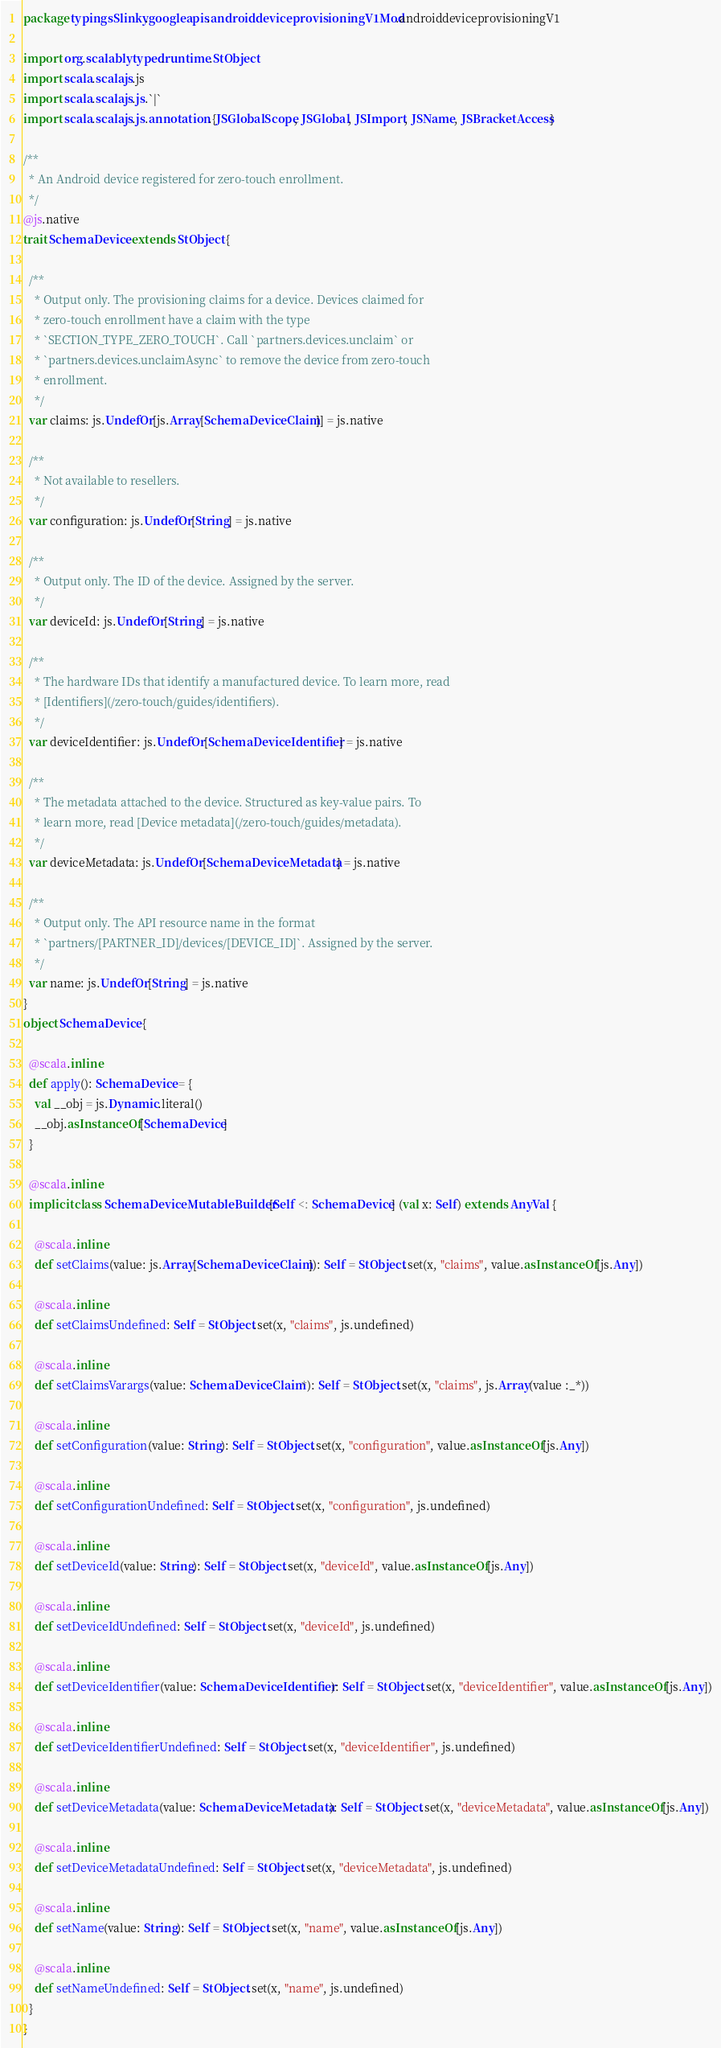Convert code to text. <code><loc_0><loc_0><loc_500><loc_500><_Scala_>package typingsSlinky.googleapis.androiddeviceprovisioningV1Mod.androiddeviceprovisioningV1

import org.scalablytyped.runtime.StObject
import scala.scalajs.js
import scala.scalajs.js.`|`
import scala.scalajs.js.annotation.{JSGlobalScope, JSGlobal, JSImport, JSName, JSBracketAccess}

/**
  * An Android device registered for zero-touch enrollment.
  */
@js.native
trait SchemaDevice extends StObject {
  
  /**
    * Output only. The provisioning claims for a device. Devices claimed for
    * zero-touch enrollment have a claim with the type
    * `SECTION_TYPE_ZERO_TOUCH`. Call `partners.devices.unclaim` or
    * `partners.devices.unclaimAsync` to remove the device from zero-touch
    * enrollment.
    */
  var claims: js.UndefOr[js.Array[SchemaDeviceClaim]] = js.native
  
  /**
    * Not available to resellers.
    */
  var configuration: js.UndefOr[String] = js.native
  
  /**
    * Output only. The ID of the device. Assigned by the server.
    */
  var deviceId: js.UndefOr[String] = js.native
  
  /**
    * The hardware IDs that identify a manufactured device. To learn more, read
    * [Identifiers](/zero-touch/guides/identifiers).
    */
  var deviceIdentifier: js.UndefOr[SchemaDeviceIdentifier] = js.native
  
  /**
    * The metadata attached to the device. Structured as key-value pairs. To
    * learn more, read [Device metadata](/zero-touch/guides/metadata).
    */
  var deviceMetadata: js.UndefOr[SchemaDeviceMetadata] = js.native
  
  /**
    * Output only. The API resource name in the format
    * `partners/[PARTNER_ID]/devices/[DEVICE_ID]`. Assigned by the server.
    */
  var name: js.UndefOr[String] = js.native
}
object SchemaDevice {
  
  @scala.inline
  def apply(): SchemaDevice = {
    val __obj = js.Dynamic.literal()
    __obj.asInstanceOf[SchemaDevice]
  }
  
  @scala.inline
  implicit class SchemaDeviceMutableBuilder[Self <: SchemaDevice] (val x: Self) extends AnyVal {
    
    @scala.inline
    def setClaims(value: js.Array[SchemaDeviceClaim]): Self = StObject.set(x, "claims", value.asInstanceOf[js.Any])
    
    @scala.inline
    def setClaimsUndefined: Self = StObject.set(x, "claims", js.undefined)
    
    @scala.inline
    def setClaimsVarargs(value: SchemaDeviceClaim*): Self = StObject.set(x, "claims", js.Array(value :_*))
    
    @scala.inline
    def setConfiguration(value: String): Self = StObject.set(x, "configuration", value.asInstanceOf[js.Any])
    
    @scala.inline
    def setConfigurationUndefined: Self = StObject.set(x, "configuration", js.undefined)
    
    @scala.inline
    def setDeviceId(value: String): Self = StObject.set(x, "deviceId", value.asInstanceOf[js.Any])
    
    @scala.inline
    def setDeviceIdUndefined: Self = StObject.set(x, "deviceId", js.undefined)
    
    @scala.inline
    def setDeviceIdentifier(value: SchemaDeviceIdentifier): Self = StObject.set(x, "deviceIdentifier", value.asInstanceOf[js.Any])
    
    @scala.inline
    def setDeviceIdentifierUndefined: Self = StObject.set(x, "deviceIdentifier", js.undefined)
    
    @scala.inline
    def setDeviceMetadata(value: SchemaDeviceMetadata): Self = StObject.set(x, "deviceMetadata", value.asInstanceOf[js.Any])
    
    @scala.inline
    def setDeviceMetadataUndefined: Self = StObject.set(x, "deviceMetadata", js.undefined)
    
    @scala.inline
    def setName(value: String): Self = StObject.set(x, "name", value.asInstanceOf[js.Any])
    
    @scala.inline
    def setNameUndefined: Self = StObject.set(x, "name", js.undefined)
  }
}
</code> 